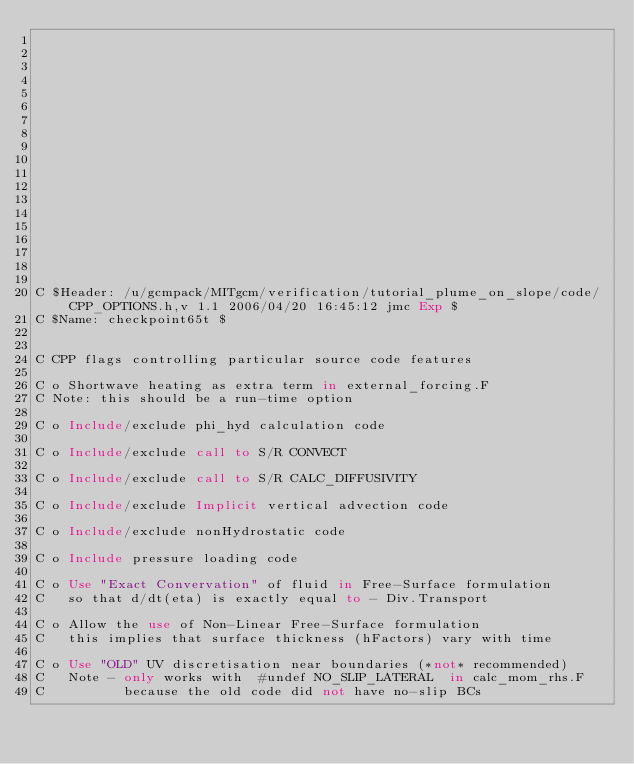Convert code to text. <code><loc_0><loc_0><loc_500><loc_500><_FORTRAN_>


















C $Header: /u/gcmpack/MITgcm/verification/tutorial_plume_on_slope/code/CPP_OPTIONS.h,v 1.1 2006/04/20 16:45:12 jmc Exp $
C $Name: checkpoint65t $


C CPP flags controlling particular source code features

C o Shortwave heating as extra term in external_forcing.F
C Note: this should be a run-time option

C o Include/exclude phi_hyd calculation code

C o Include/exclude call to S/R CONVECT

C o Include/exclude call to S/R CALC_DIFFUSIVITY

C o Include/exclude Implicit vertical advection code

C o Include/exclude nonHydrostatic code

C o Include pressure loading code

C o Use "Exact Convervation" of fluid in Free-Surface formulation
C   so that d/dt(eta) is exactly equal to - Div.Transport

C o Allow the use of Non-Linear Free-Surface formulation
C   this implies that surface thickness (hFactors) vary with time

C o Use "OLD" UV discretisation near boundaries (*not* recommended)
C   Note - only works with  #undef NO_SLIP_LATERAL  in calc_mom_rhs.F
C          because the old code did not have no-slip BCs
</code> 